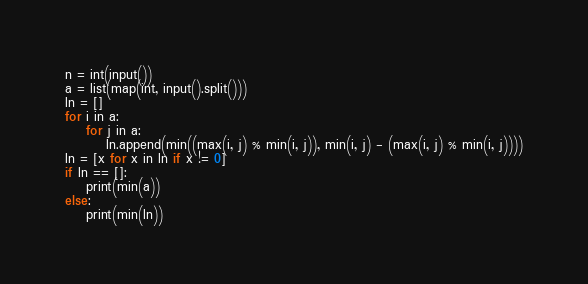Convert code to text. <code><loc_0><loc_0><loc_500><loc_500><_Python_>n = int(input())
a = list(map(int, input().split()))
ln = []
for i in a:
    for j in a:
        ln.append(min((max(i, j) % min(i, j)), min(i, j) - (max(i, j) % min(i, j))))
ln = [x for x in ln if x != 0]
if ln == []:
    print(min(a))
else:
    print(min(ln))</code> 